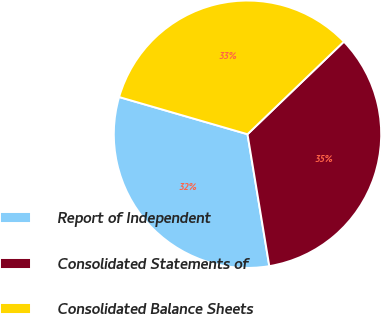<chart> <loc_0><loc_0><loc_500><loc_500><pie_chart><fcel>Report of Independent<fcel>Consolidated Statements of<fcel>Consolidated Balance Sheets<nl><fcel>32.1%<fcel>34.57%<fcel>33.33%<nl></chart> 